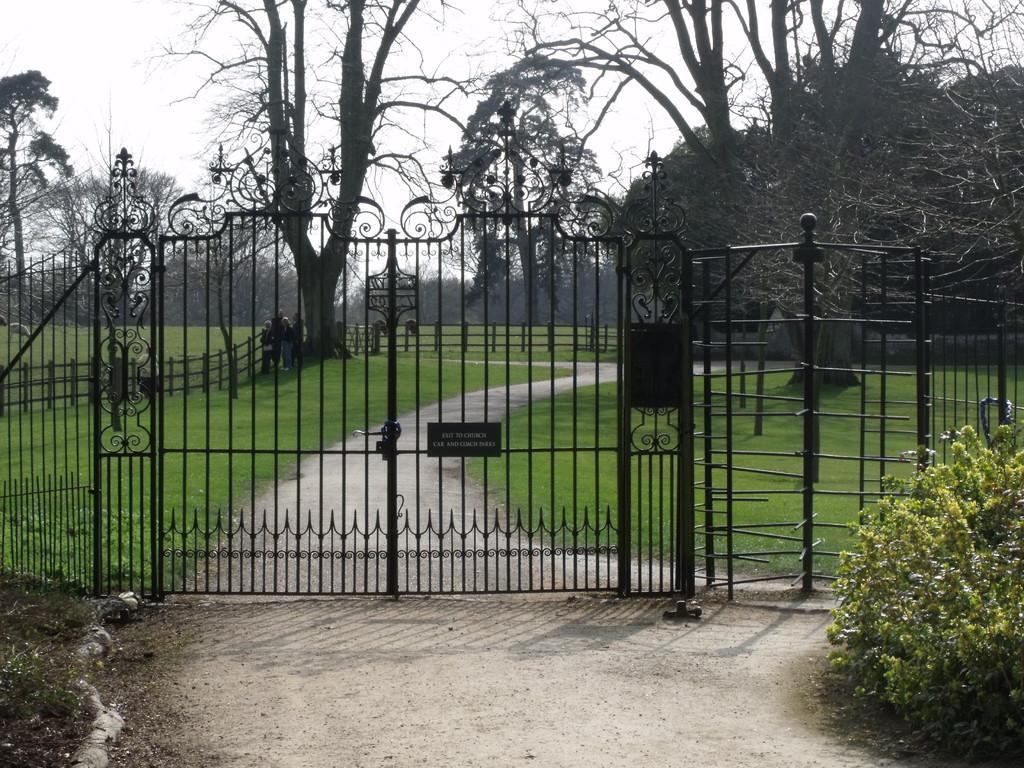Can you describe this image briefly? In the center of the image there is a gate. On the right we can see a bush. In the background there are trees, fence and sky. 